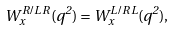<formula> <loc_0><loc_0><loc_500><loc_500>W _ { x } ^ { R / L \, R } ( q ^ { 2 } ) = W _ { x } ^ { L / R \, L } ( q ^ { 2 } ) ,</formula> 